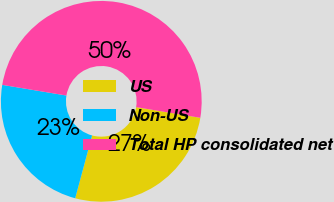Convert chart to OTSL. <chart><loc_0><loc_0><loc_500><loc_500><pie_chart><fcel>US<fcel>Non-US<fcel>Total HP consolidated net<nl><fcel>26.56%<fcel>23.44%<fcel>50.0%<nl></chart> 